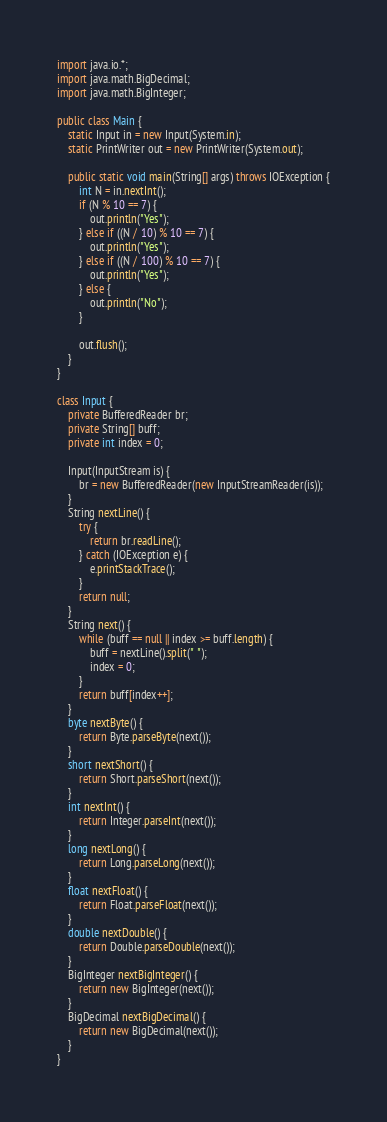<code> <loc_0><loc_0><loc_500><loc_500><_Java_>import java.io.*;
import java.math.BigDecimal;
import java.math.BigInteger;

public class Main {
    static Input in = new Input(System.in);
    static PrintWriter out = new PrintWriter(System.out);

    public static void main(String[] args) throws IOException {
        int N = in.nextInt();
        if (N % 10 == 7) {
            out.println("Yes");
        } else if ((N / 10) % 10 == 7) {
            out.println("Yes");
        } else if ((N / 100) % 10 == 7) {
            out.println("Yes");
        } else {
            out.println("No");
        }

        out.flush();
    }
}

class Input {
    private BufferedReader br;
    private String[] buff;
    private int index = 0;

    Input(InputStream is) {
        br = new BufferedReader(new InputStreamReader(is));
    }
    String nextLine() {
        try {
            return br.readLine();
        } catch (IOException e) {
            e.printStackTrace();
        }
        return null;
    }
    String next() {
        while (buff == null || index >= buff.length) {
            buff = nextLine().split(" ");
            index = 0;
        }
        return buff[index++];
    }
    byte nextByte() {
        return Byte.parseByte(next());
    }
    short nextShort() {
        return Short.parseShort(next());
    }
    int nextInt() {
        return Integer.parseInt(next());
    }
    long nextLong() {
        return Long.parseLong(next());
    }
    float nextFloat() {
        return Float.parseFloat(next());
    }
    double nextDouble() {
        return Double.parseDouble(next());
    }
    BigInteger nextBigInteger() {
        return new BigInteger(next());
    }
    BigDecimal nextBigDecimal() {
        return new BigDecimal(next());
    }
}</code> 